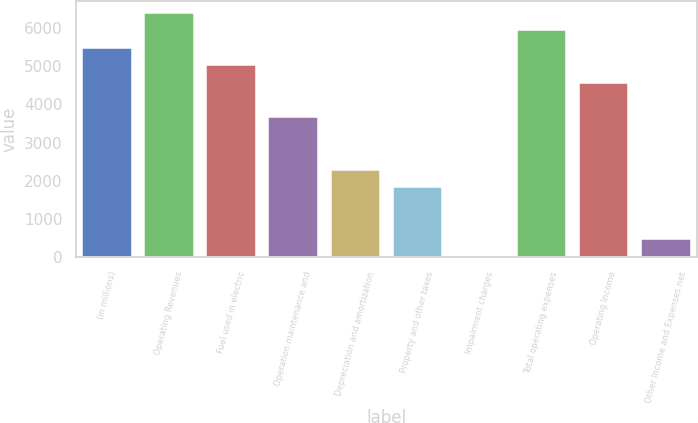Convert chart. <chart><loc_0><loc_0><loc_500><loc_500><bar_chart><fcel>(in millions)<fcel>Operating Revenues<fcel>Fuel used in electric<fcel>Operation maintenance and<fcel>Depreciation and amortization<fcel>Property and other taxes<fcel>Impairment charges<fcel>Total operating expenses<fcel>Operating Income<fcel>Other Income and Expenses net<nl><fcel>5480.4<fcel>6392.8<fcel>5024.2<fcel>3655.6<fcel>2287<fcel>1830.8<fcel>6<fcel>5936.6<fcel>4568<fcel>462.2<nl></chart> 